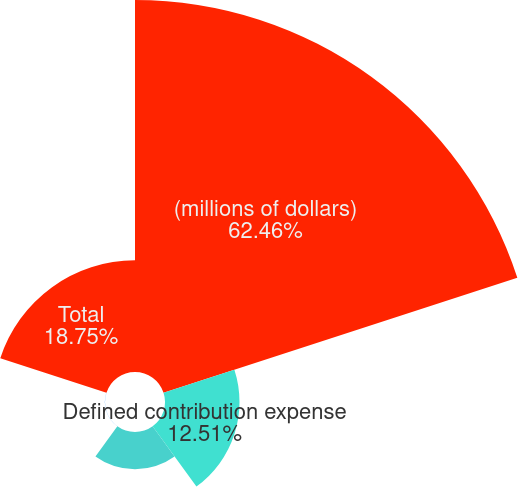<chart> <loc_0><loc_0><loc_500><loc_500><pie_chart><fcel>(millions of dollars)<fcel>Defined contribution expense<fcel>Defined benefit pension<fcel>Other postretirement employee<fcel>Total<nl><fcel>62.47%<fcel>12.51%<fcel>6.26%<fcel>0.02%<fcel>18.75%<nl></chart> 